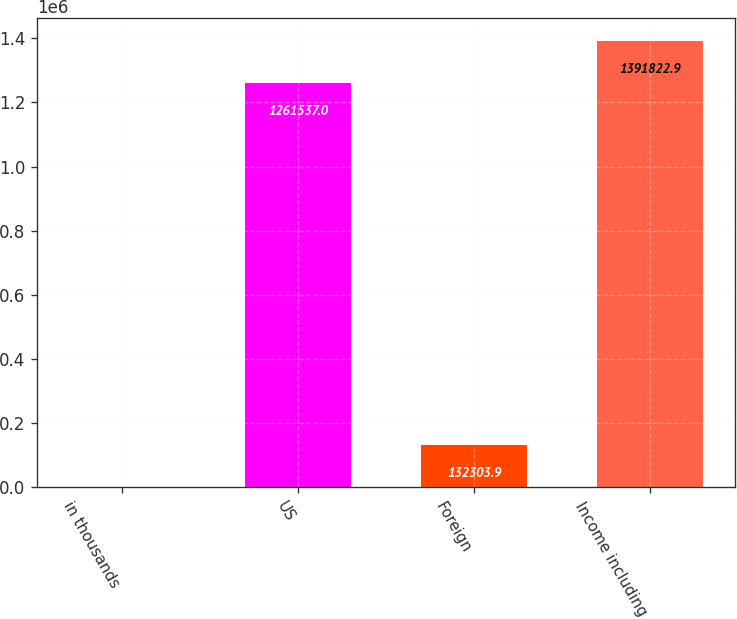<chart> <loc_0><loc_0><loc_500><loc_500><bar_chart><fcel>in thousands<fcel>US<fcel>Foreign<fcel>Income including<nl><fcel>2018<fcel>1.26154e+06<fcel>132304<fcel>1.39182e+06<nl></chart> 